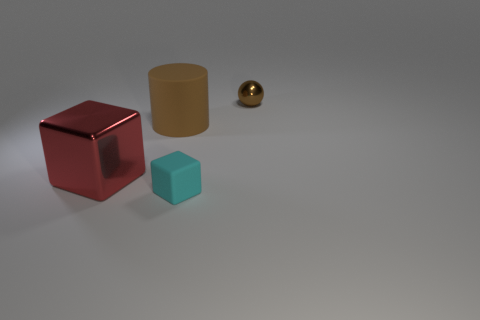Add 4 small red spheres. How many objects exist? 8 Subtract all spheres. How many objects are left? 3 Subtract all big brown cylinders. Subtract all big brown matte things. How many objects are left? 2 Add 1 big rubber cylinders. How many big rubber cylinders are left? 2 Add 2 tiny brown metal spheres. How many tiny brown metal spheres exist? 3 Subtract 0 blue blocks. How many objects are left? 4 